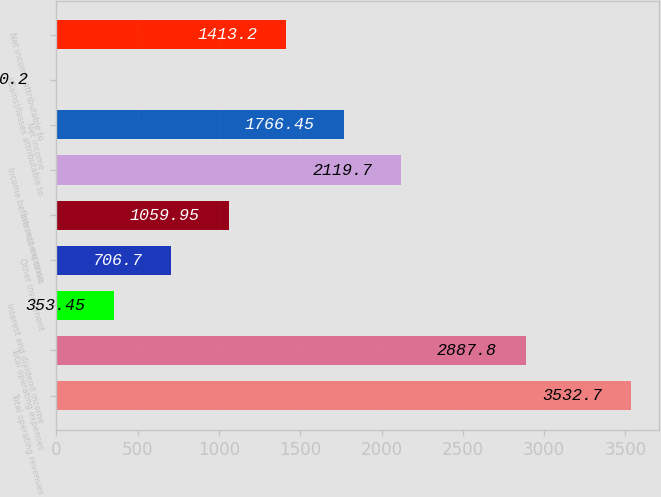Convert chart. <chart><loc_0><loc_0><loc_500><loc_500><bar_chart><fcel>Total operating revenues<fcel>Total operating expenses<fcel>Interest and dividend income<fcel>Other investment<fcel>Interest expense<fcel>Income before income taxes<fcel>Net income<fcel>(Gains)/losses attributable to<fcel>Net income attributable to<nl><fcel>3532.7<fcel>2887.8<fcel>353.45<fcel>706.7<fcel>1059.95<fcel>2119.7<fcel>1766.45<fcel>0.2<fcel>1413.2<nl></chart> 